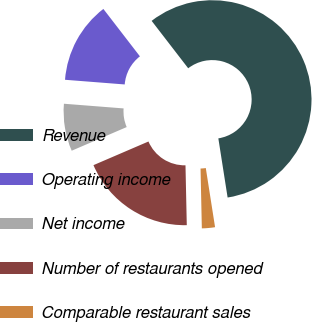Convert chart to OTSL. <chart><loc_0><loc_0><loc_500><loc_500><pie_chart><fcel>Revenue<fcel>Operating income<fcel>Net income<fcel>Number of restaurants opened<fcel>Comparable restaurant sales<nl><fcel>57.98%<fcel>13.3%<fcel>7.71%<fcel>18.88%<fcel>2.13%<nl></chart> 